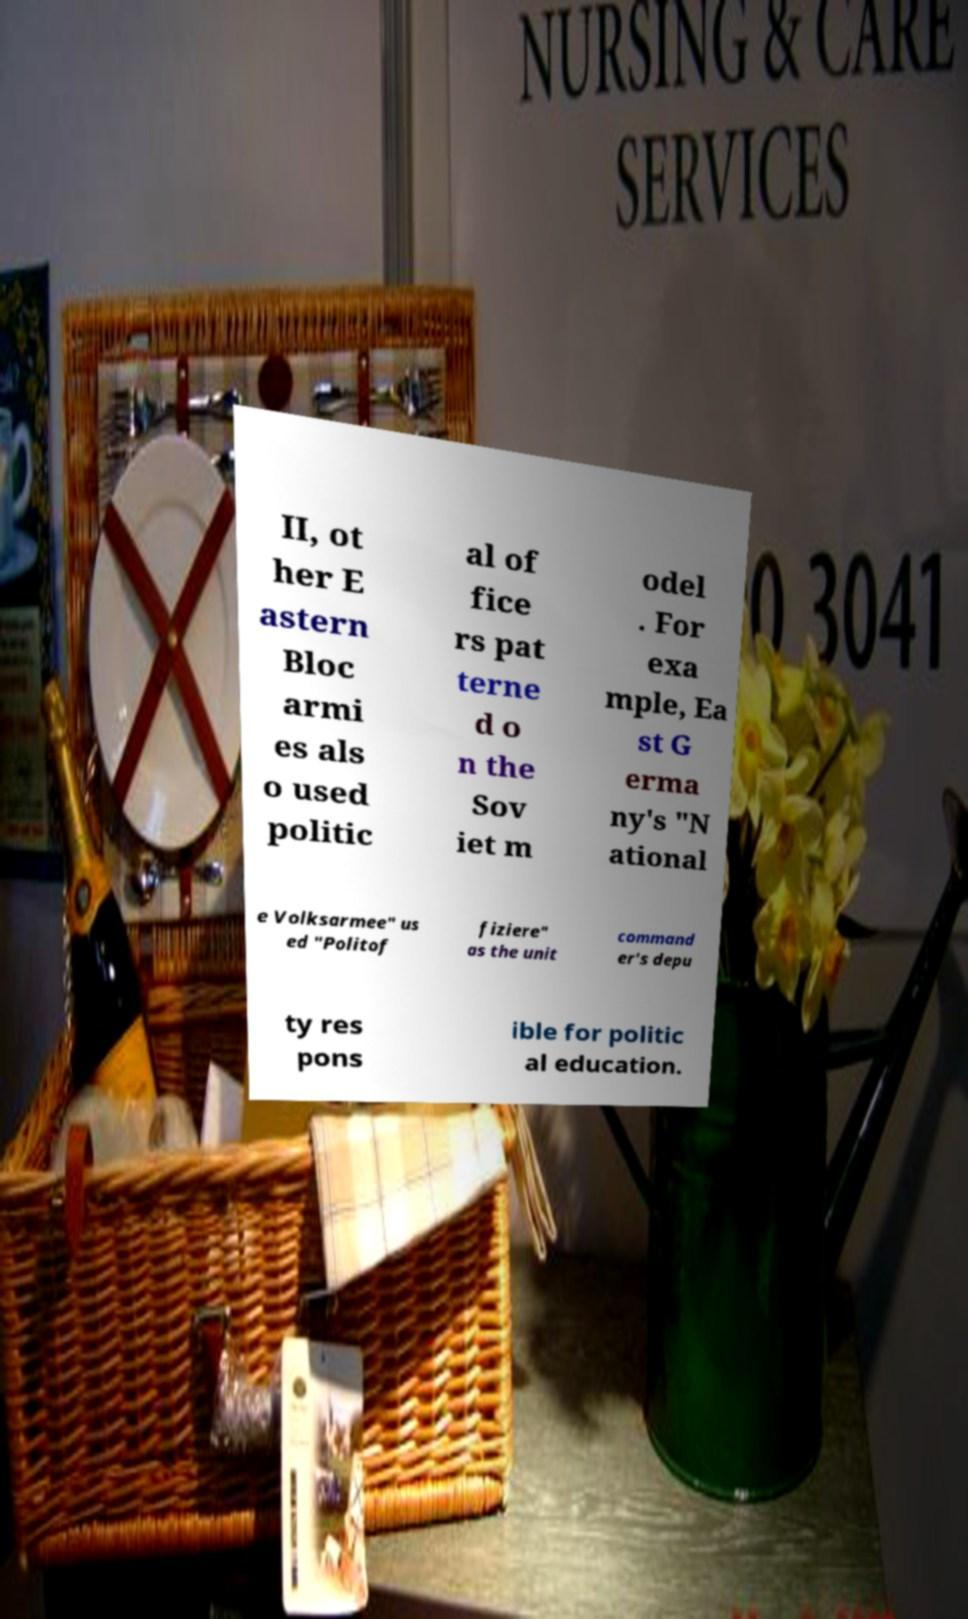I need the written content from this picture converted into text. Can you do that? II, ot her E astern Bloc armi es als o used politic al of fice rs pat terne d o n the Sov iet m odel . For exa mple, Ea st G erma ny's "N ational e Volksarmee" us ed "Politof fiziere" as the unit command er's depu ty res pons ible for politic al education. 